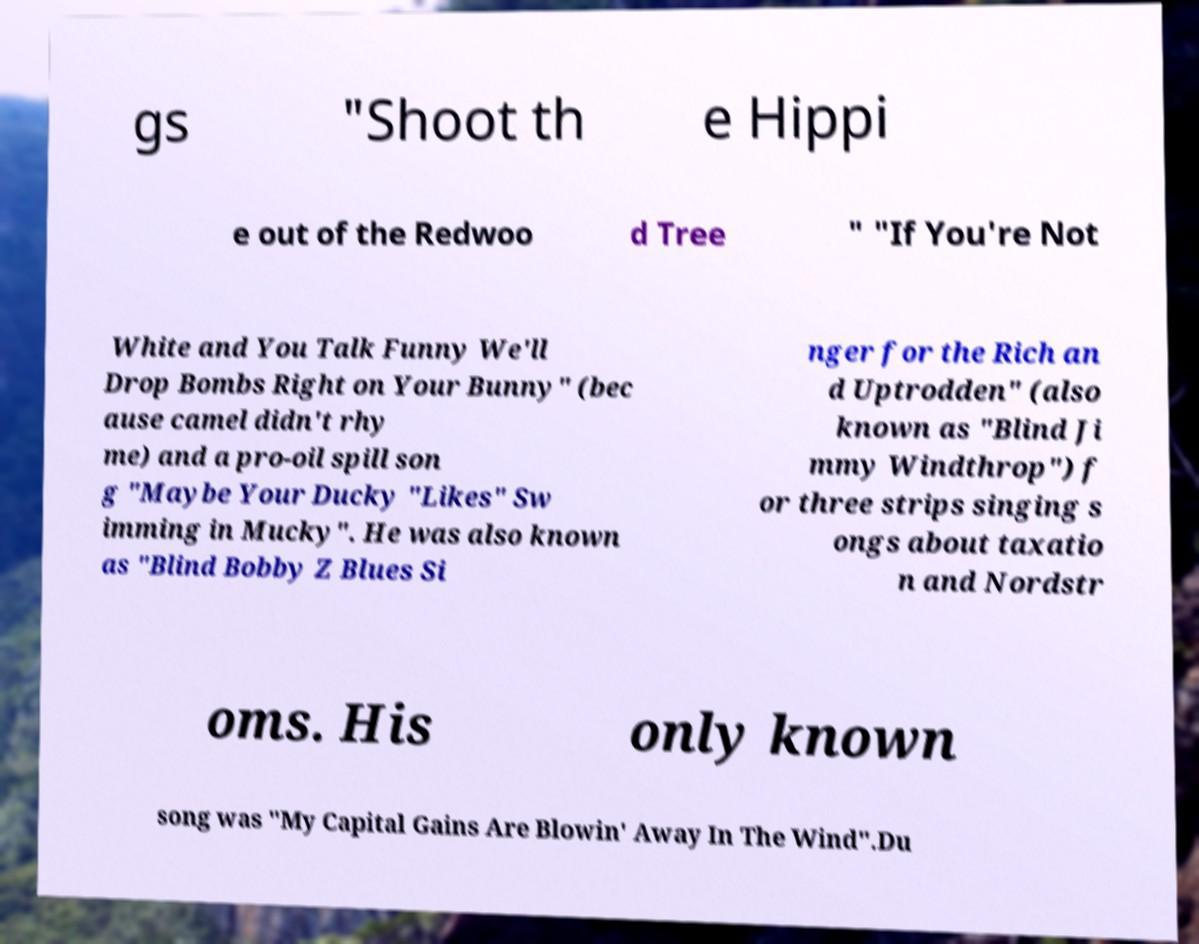Could you assist in decoding the text presented in this image and type it out clearly? gs "Shoot th e Hippi e out of the Redwoo d Tree " "If You're Not White and You Talk Funny We'll Drop Bombs Right on Your Bunny" (bec ause camel didn't rhy me) and a pro-oil spill son g "Maybe Your Ducky "Likes" Sw imming in Mucky". He was also known as "Blind Bobby Z Blues Si nger for the Rich an d Uptrodden" (also known as "Blind Ji mmy Windthrop") f or three strips singing s ongs about taxatio n and Nordstr oms. His only known song was "My Capital Gains Are Blowin' Away In The Wind".Du 